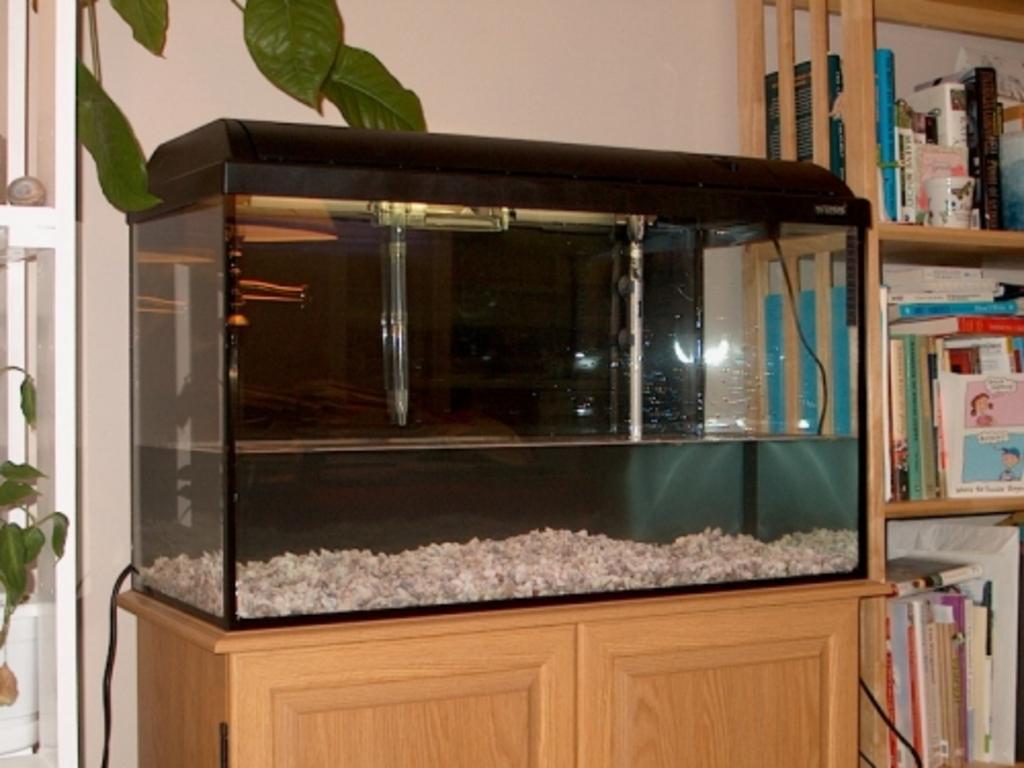How would you summarize this image in a sentence or two? In this image we can see an aquarium on the cabinet, books and some objects arranged in the cupboard and creeper plants. 